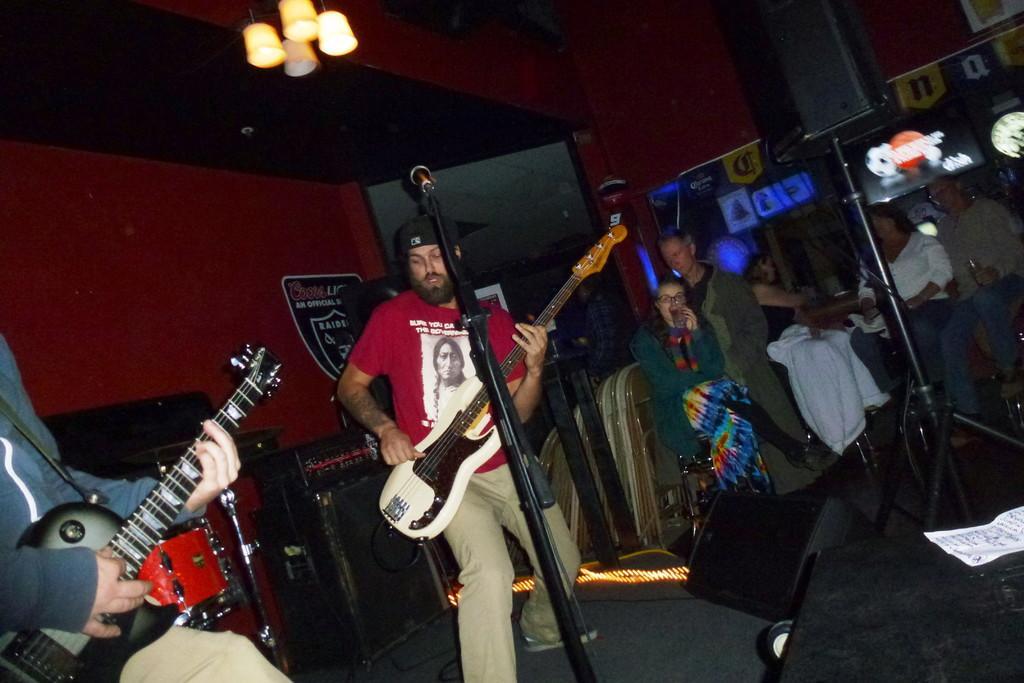Describe this image in one or two sentences. In this image I can see a person standing and playing a musical instrument. In front I can see a microphone, background I can see few other people standing, few lights and the wall is in red color. 